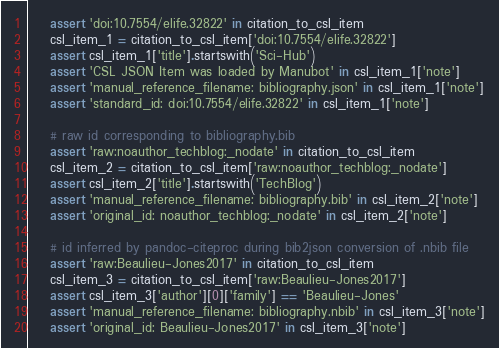<code> <loc_0><loc_0><loc_500><loc_500><_Python_>
    assert 'doi:10.7554/elife.32822' in citation_to_csl_item
    csl_item_1 = citation_to_csl_item['doi:10.7554/elife.32822']
    assert csl_item_1['title'].startswith('Sci-Hub')
    assert 'CSL JSON Item was loaded by Manubot' in csl_item_1['note']
    assert 'manual_reference_filename: bibliography.json' in csl_item_1['note']
    assert 'standard_id: doi:10.7554/elife.32822' in csl_item_1['note']

    # raw id corresponding to bibliography.bib
    assert 'raw:noauthor_techblog:_nodate' in citation_to_csl_item
    csl_item_2 = citation_to_csl_item['raw:noauthor_techblog:_nodate']
    assert csl_item_2['title'].startswith('TechBlog')
    assert 'manual_reference_filename: bibliography.bib' in csl_item_2['note']
    assert 'original_id: noauthor_techblog:_nodate' in csl_item_2['note']

    # id inferred by pandoc-citeproc during bib2json conversion of .nbib file
    assert 'raw:Beaulieu-Jones2017' in citation_to_csl_item
    csl_item_3 = citation_to_csl_item['raw:Beaulieu-Jones2017']
    assert csl_item_3['author'][0]['family'] == 'Beaulieu-Jones'
    assert 'manual_reference_filename: bibliography.nbib' in csl_item_3['note']
    assert 'original_id: Beaulieu-Jones2017' in csl_item_3['note']
</code> 